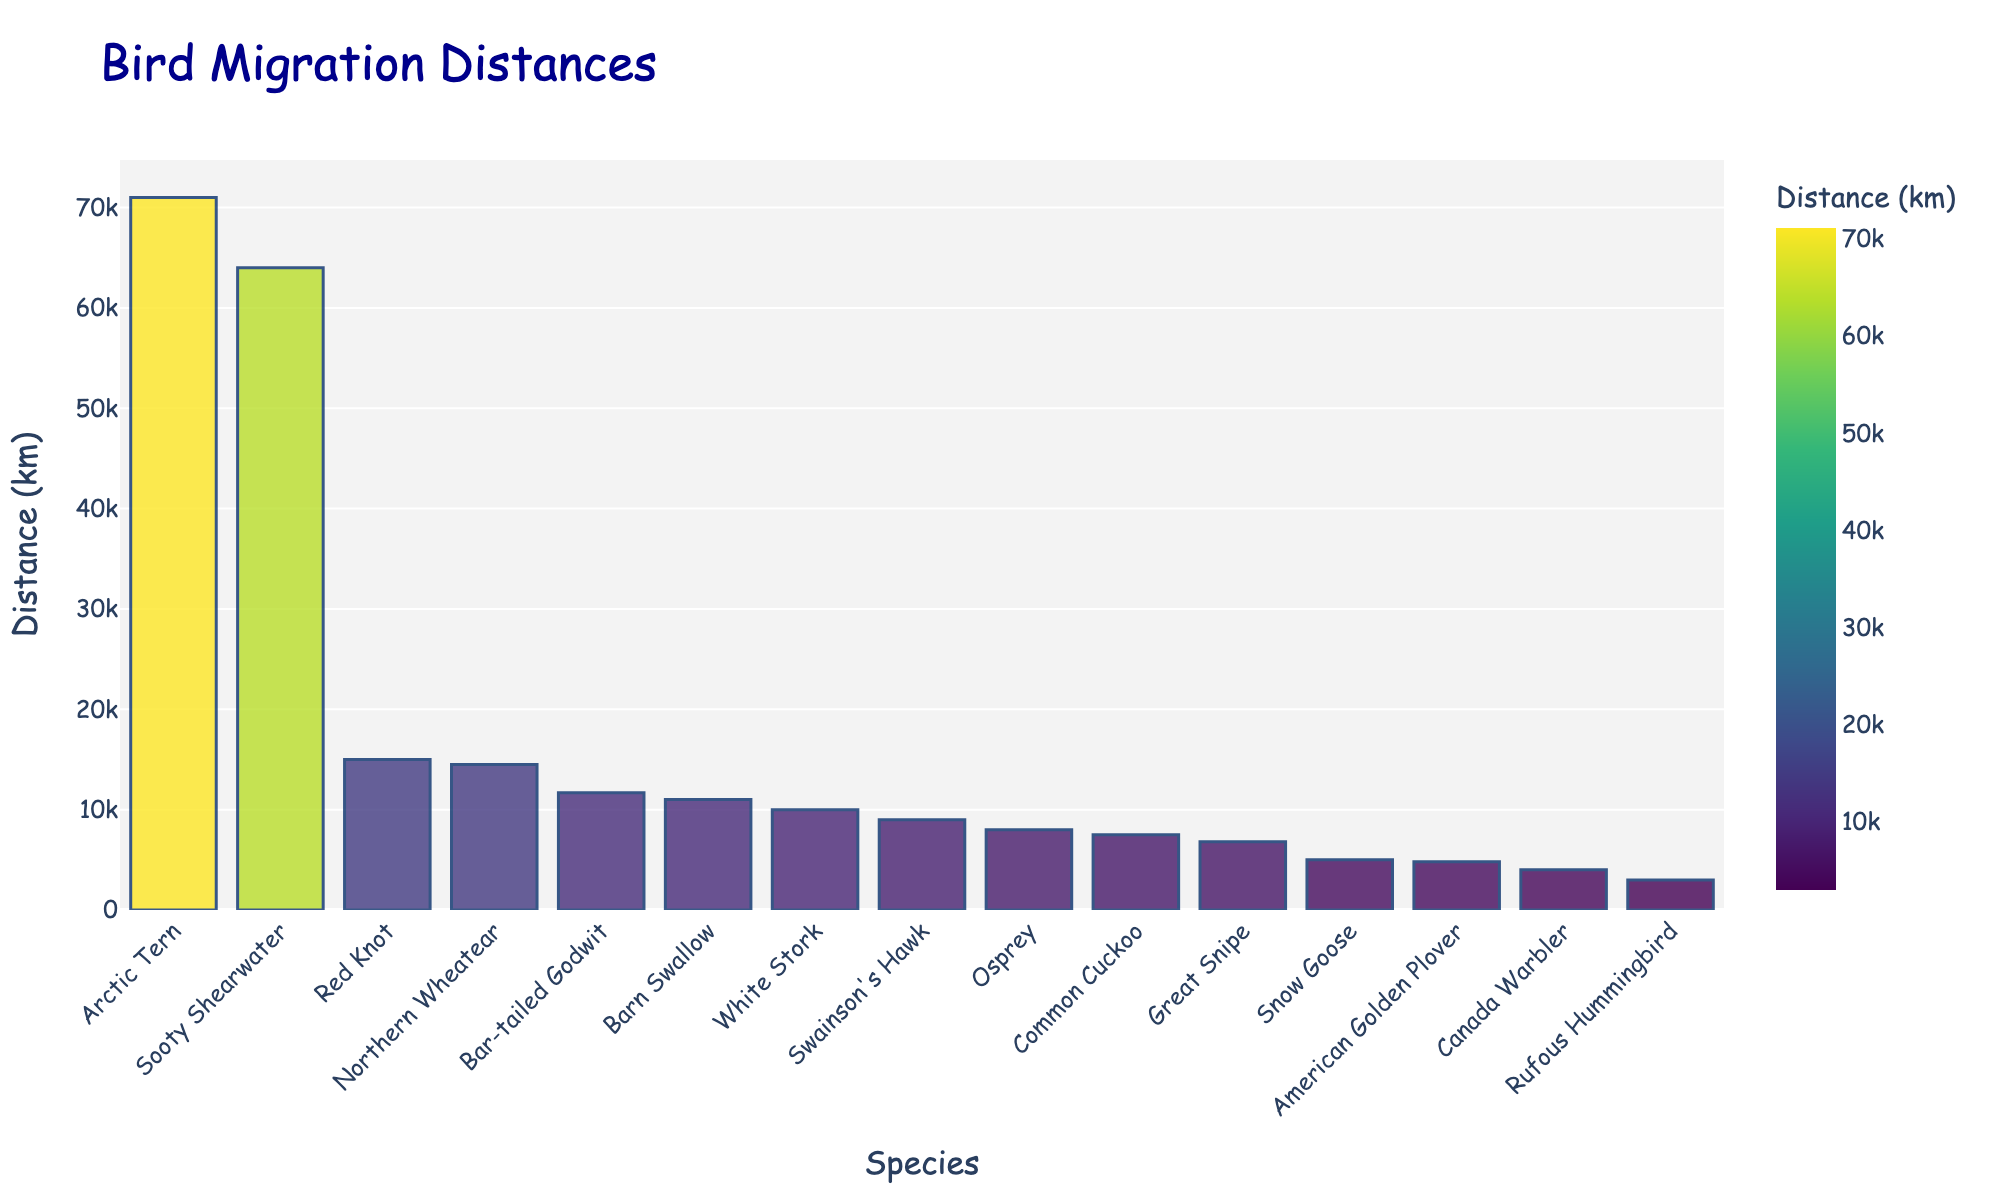How many more kilometers does the Arctic Tern migrate compared to the Barn Swallow? The Arctic Tern migrates 71,000 km, and the Barn Swallow migrates 11,000 km. The difference is 71,000 km - 11,000 km = 60,000 km.
Answer: 60,000 km Which species migrates the shortest distance? By comparing the migration distances on the bar chart, the Rufous Hummingbird migrates the shortest distance of 3,000 km.
Answer: Rufous Hummingbird Are there any species that migrate a distance between 5,000 km and 10,000 km? The species in the given range are Great Snipe (6,800 km), Common Cuckoo (7,500 km), Osprey (8,000 km), and Swainson's Hawk (9,000 km).
Answer: Great Snipe, Common Cuckoo, Osprey, Swainson's Hawk What's the total migration distance of the Sooty Shearwater and the Northern Wheatear? The Sooty Shearwater migrates 64,000 km, and the Northern Wheatear migrates 14,500 km. Their total is 64,000 km + 14,500 km = 78,500 km.
Answer: 78,500 km Which species has the second-longest migration distance? After the Arctic Tern (71,000 km) and Sooty Shearwater (64,000 km), the Bar-tailed Godwit migrates the second-longest distance of 11,680 km.
Answer: Bar-tailed Godwit Is the migration distance of the Snow Goose greater than the Canada Warbler? The Snow Goose migrates 5,000 km, whereas the Canada Warbler migrates 4,000 km. Since 5,000 km is greater than 4,000 km, the Snow Goose has a greater migration distance.
Answer: Yes What's the average migration distance of the Red Knot, the Osprey, and the White Stork? The Red Knot migrates 15,000 km, the Osprey migrates 8,000 km, and the White Stork migrates 10,000 km. The average is (15,000 km + 8,000 km + 10,000 km) / 3 ≈ 11,000 km.
Answer: 11,000 km Which species migrate less than 7,000 km? Rufous Hummingbird (3,000 km), American Golden Plover (4,800 km), Canada Warbler (4,000 km), Snow Goose (5,000 km), and Great Snipe (6,800 km) migrate less than 7,000 km.
Answer: Rufous Hummingbird, American Golden Plover, Canada Warbler, Snow Goose, Great Snipe What's the difference in migration distance between the Great Snipe and the Northern Wheatear? The Northern Wheatear migrates 14,500 km, and the Great Snipe migrates 6,800 km. The difference is 14,500 km - 6,800 km = 7,700 km.
Answer: 7,700 km Which species appears in the middle of the sorted bar chart based on migration distances? Sorting the species by migration distance, the middle value would be the 8th in a list of 15 species. The 8th species in sorted order is the White Stork, migrating 10,000 km.
Answer: White Stork 